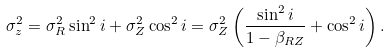<formula> <loc_0><loc_0><loc_500><loc_500>\sigma _ { z } ^ { 2 } = \sigma ^ { 2 } _ { R } \sin ^ { 2 } i + \sigma _ { Z } ^ { 2 } \cos ^ { 2 } i = \sigma _ { Z } ^ { 2 } \left ( \frac { \sin ^ { 2 } i } { 1 - \beta _ { R Z } } + \cos ^ { 2 } i \right ) .</formula> 